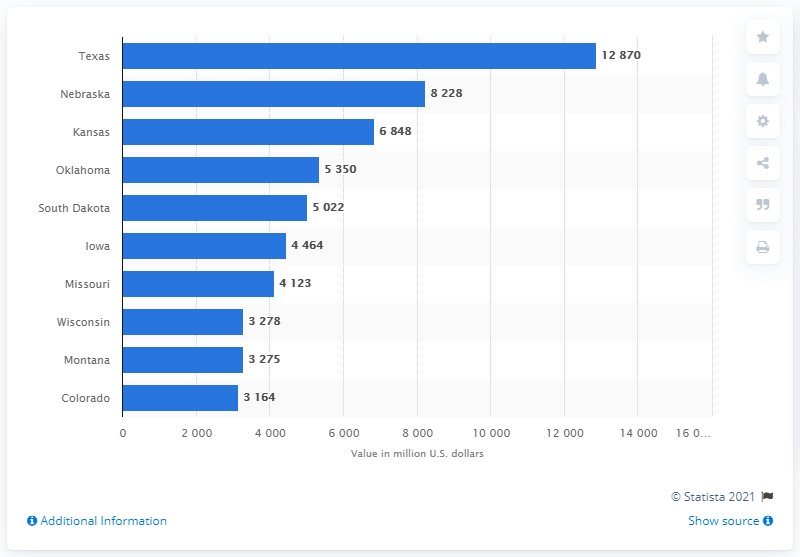List a handful of essential elements in this visual. According to data from 2019, the state of Nebraska had the highest total value of cattle and calves. In 2019, Nebraska's total value of cattle and calves was 82,288 dollars. 